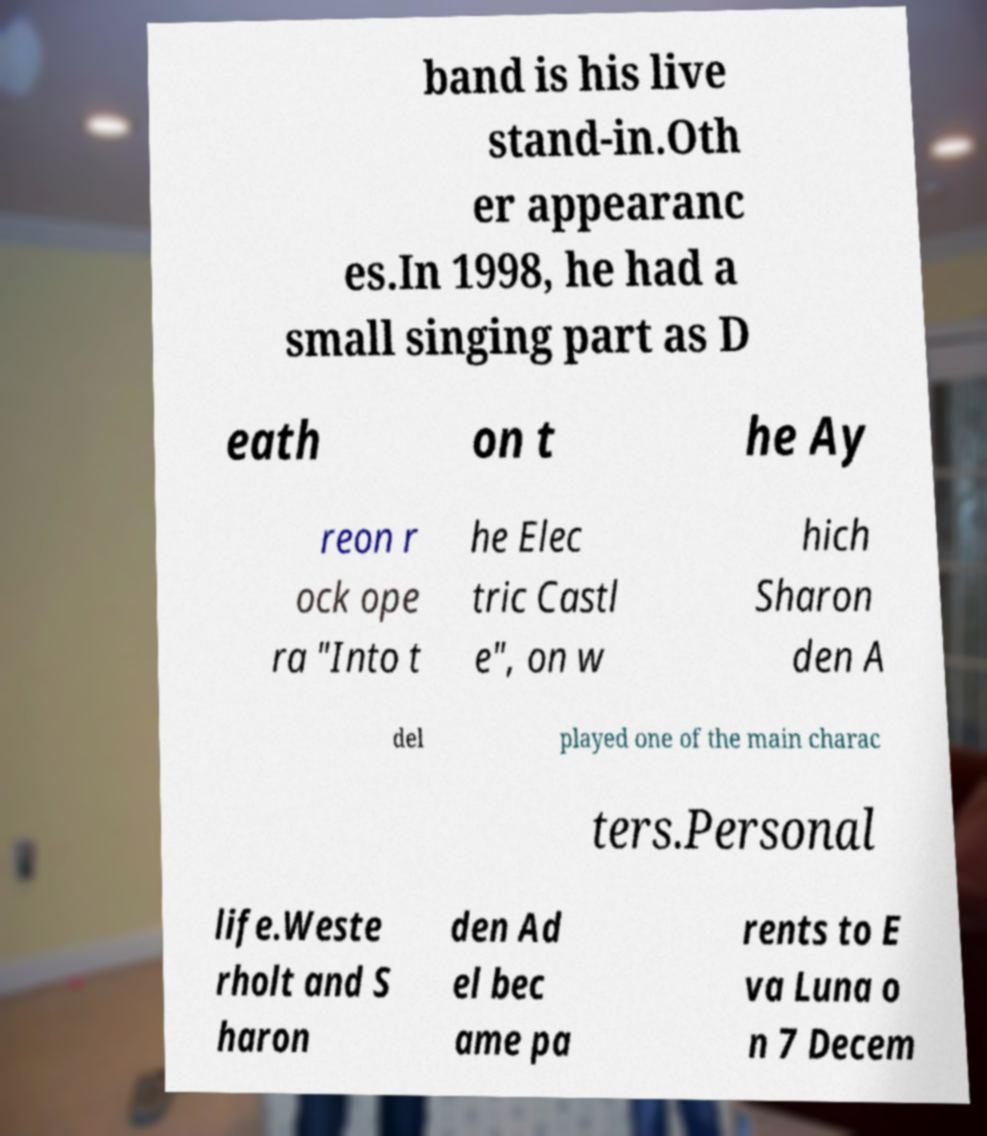Could you extract and type out the text from this image? band is his live stand-in.Oth er appearanc es.In 1998, he had a small singing part as D eath on t he Ay reon r ock ope ra "Into t he Elec tric Castl e", on w hich Sharon den A del played one of the main charac ters.Personal life.Weste rholt and S haron den Ad el bec ame pa rents to E va Luna o n 7 Decem 